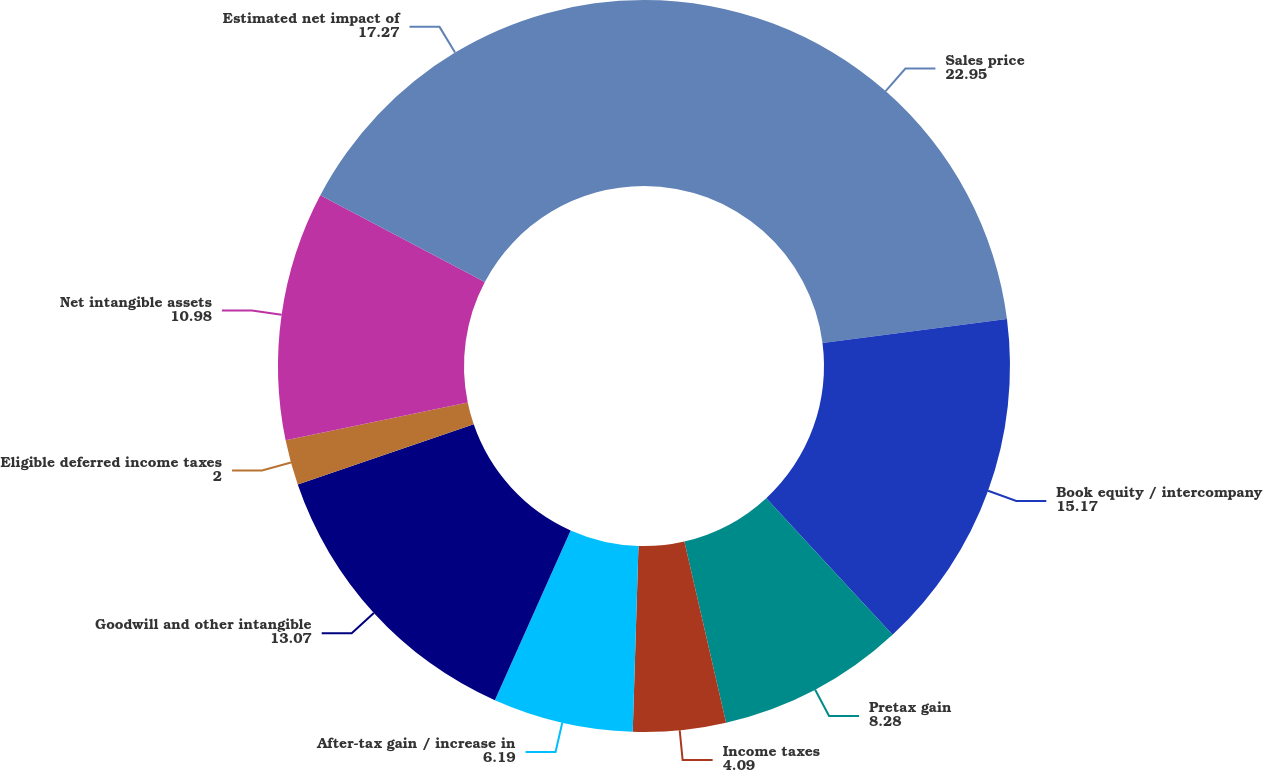<chart> <loc_0><loc_0><loc_500><loc_500><pie_chart><fcel>Sales price<fcel>Book equity / intercompany<fcel>Pretax gain<fcel>Income taxes<fcel>After-tax gain / increase in<fcel>Goodwill and other intangible<fcel>Eligible deferred income taxes<fcel>Net intangible assets<fcel>Estimated net impact of<nl><fcel>22.95%<fcel>15.17%<fcel>8.28%<fcel>4.09%<fcel>6.19%<fcel>13.07%<fcel>2.0%<fcel>10.98%<fcel>17.27%<nl></chart> 